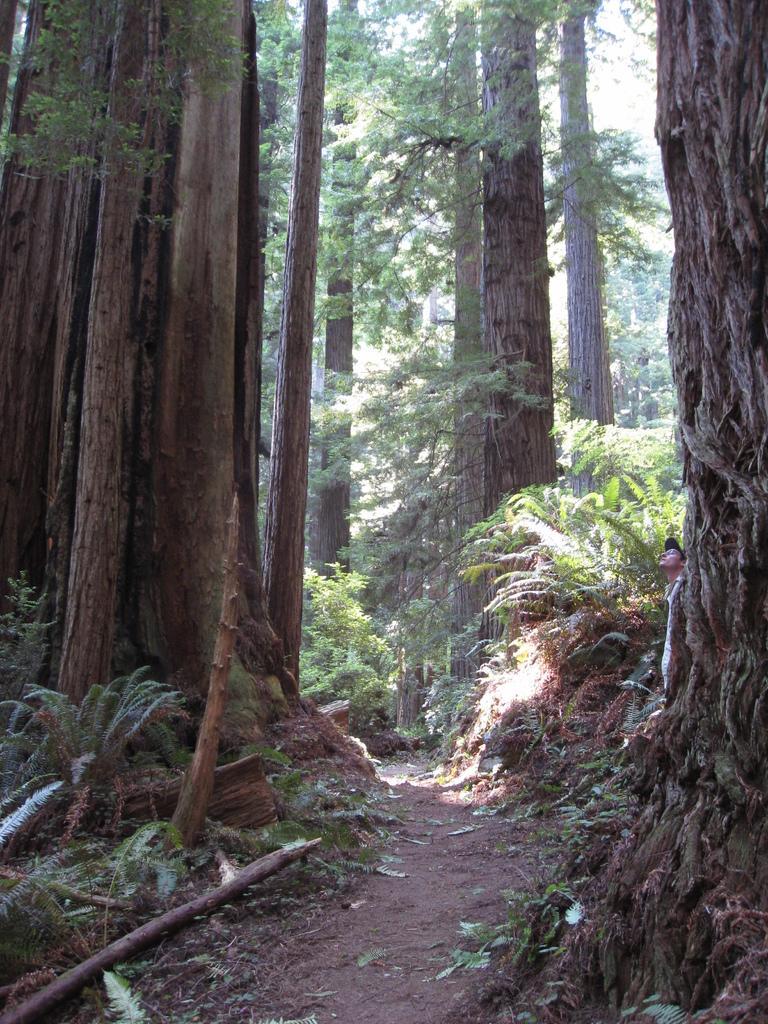Please provide a concise description of this image. In this image I can see the path, few wooden logs, few trees, a person wearing black hat is standing and few leaves on the ground. In the background I can see the sky. 